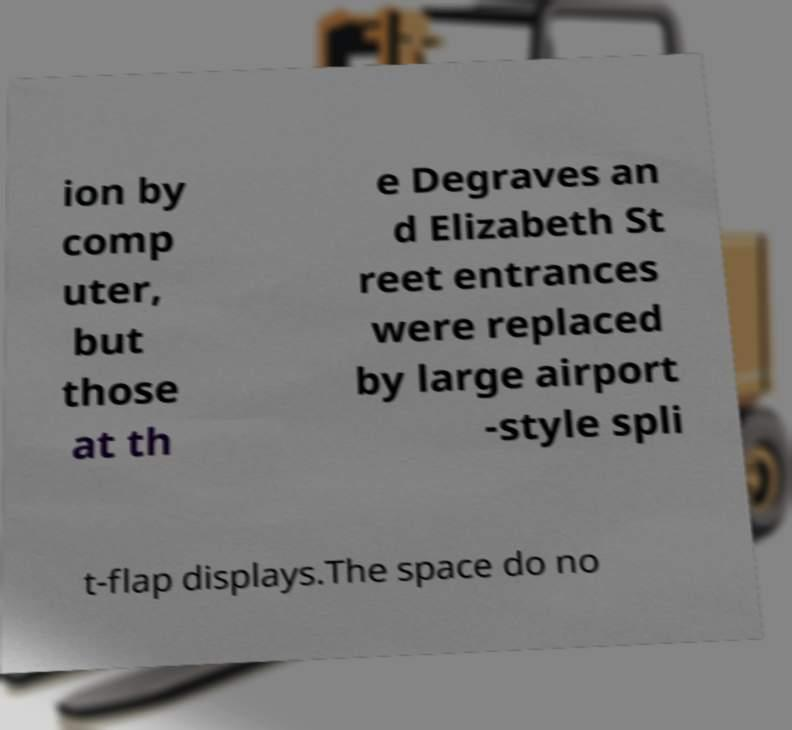Can you read and provide the text displayed in the image?This photo seems to have some interesting text. Can you extract and type it out for me? ion by comp uter, but those at th e Degraves an d Elizabeth St reet entrances were replaced by large airport -style spli t-flap displays.The space do no 